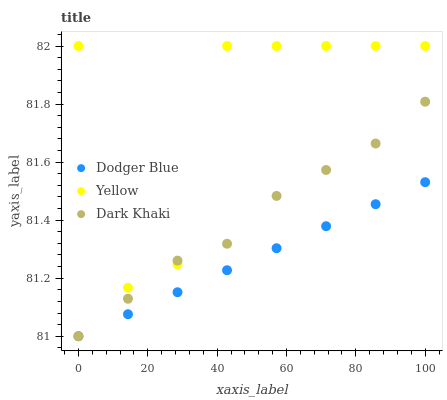Does Dodger Blue have the minimum area under the curve?
Answer yes or no. Yes. Does Yellow have the maximum area under the curve?
Answer yes or no. Yes. Does Yellow have the minimum area under the curve?
Answer yes or no. No. Does Dodger Blue have the maximum area under the curve?
Answer yes or no. No. Is Dodger Blue the smoothest?
Answer yes or no. Yes. Is Yellow the roughest?
Answer yes or no. Yes. Is Yellow the smoothest?
Answer yes or no. No. Is Dodger Blue the roughest?
Answer yes or no. No. Does Dark Khaki have the lowest value?
Answer yes or no. Yes. Does Yellow have the lowest value?
Answer yes or no. No. Does Yellow have the highest value?
Answer yes or no. Yes. Does Dodger Blue have the highest value?
Answer yes or no. No. Is Dodger Blue less than Yellow?
Answer yes or no. Yes. Is Yellow greater than Dodger Blue?
Answer yes or no. Yes. Does Dark Khaki intersect Yellow?
Answer yes or no. Yes. Is Dark Khaki less than Yellow?
Answer yes or no. No. Is Dark Khaki greater than Yellow?
Answer yes or no. No. Does Dodger Blue intersect Yellow?
Answer yes or no. No. 